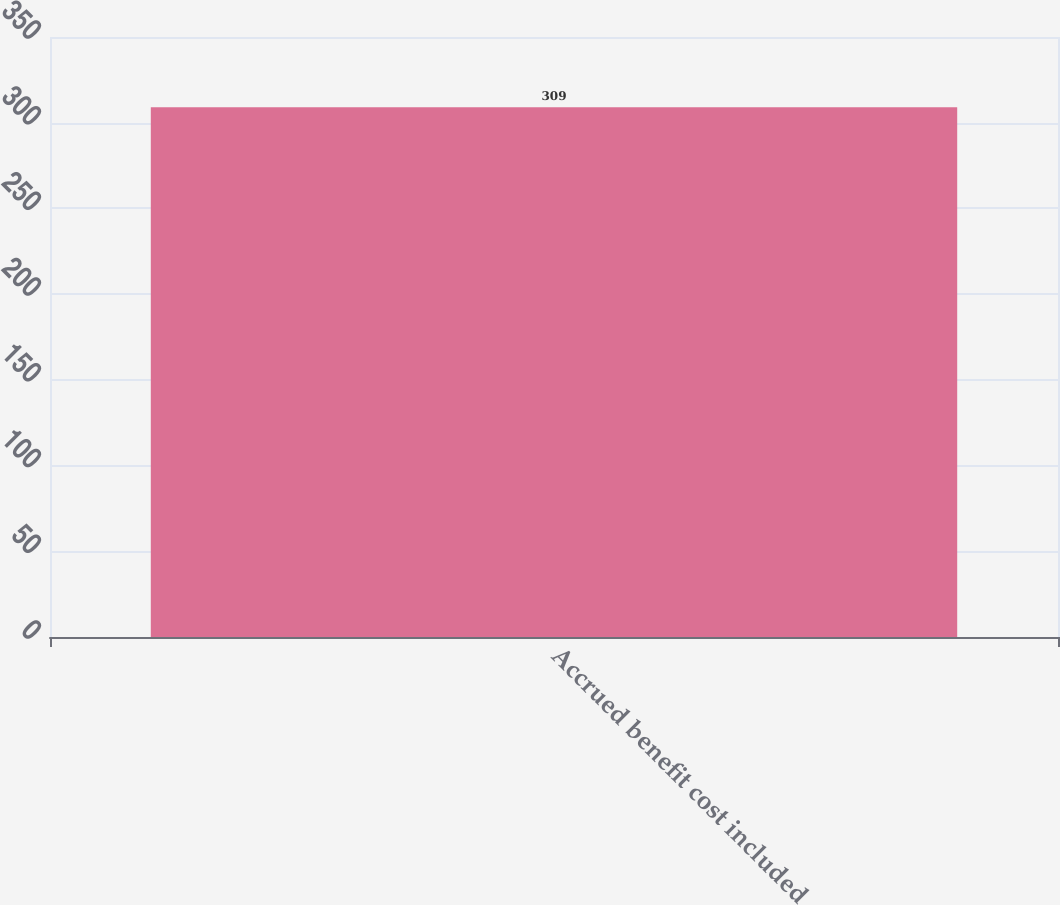Convert chart. <chart><loc_0><loc_0><loc_500><loc_500><bar_chart><fcel>Accrued benefit cost included<nl><fcel>309<nl></chart> 